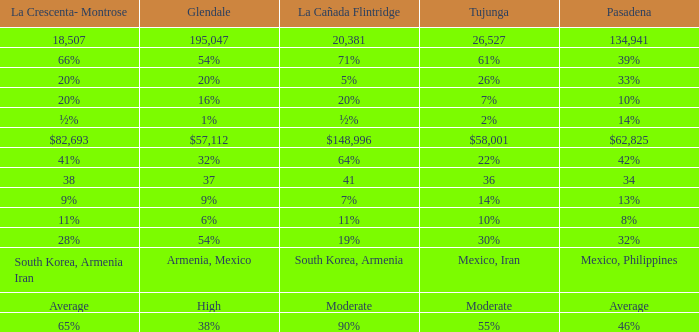What is the figure for Pasadena when Tujunga is 36? 34.0. 